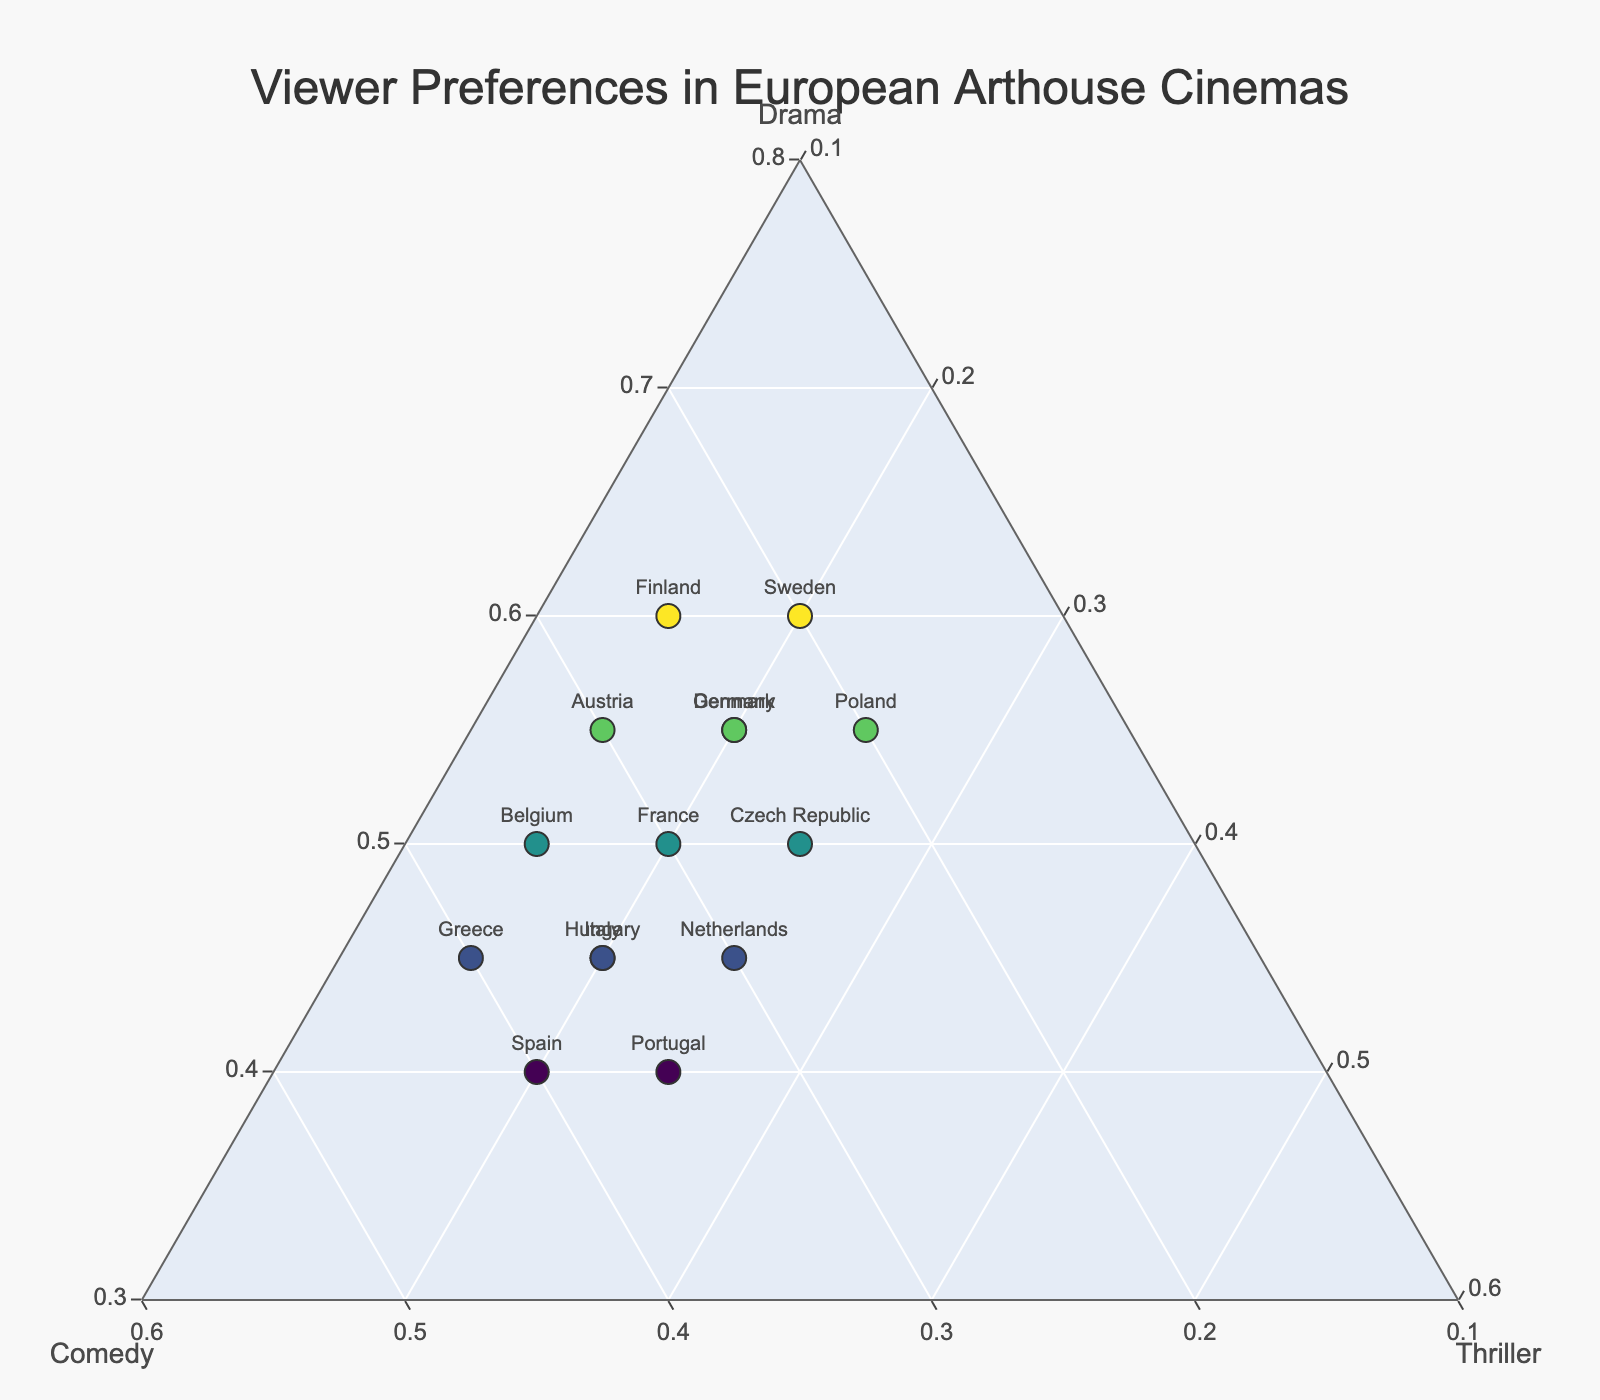Which country has the highest preference for Drama? You can identify the country with the highest percentage for Drama by looking at the points along the 'Drama' axis. The country with the highest value is Sweden with 60%.
Answer: Sweden Which countries have an equal preference for Comedy? You need to identify the countries that have the same value along the 'Comedy' axis. Both Greece and Spain have a 40% preference for Comedy.
Answer: Greece and Spain What's the difference in Thriller preference between Poland and Greece? Poland has a Thriller preference of 25%, and Greece has 15%. The difference is calculated as 25% - 15% = 10%.
Answer: 10% Which country has the most balanced viewer preferences? Balanced preferences would mean the values for Drama, Comedy, and Thriller are close to each other. Spain has 40% Drama, 40% Comedy, and 20% Thriller, which shows a good balance.
Answer: Spain How many countries have a Thriller preference below 20%? Count the number of countries where the Thriller value is less than 20%. Those countries are France, Belgium, Austria, Greece, and Finland, total is 5.
Answer: 5 Compare the Comedy preferences between France and the Netherlands. Which country has a higher preference? France has a Comedy preference of 30%, while the Netherlands has 30% as well. Since they are equal, neither has a higher preference.
Answer: Equal What's the average Drama preference across all countries? Sum up all the Drama preferences and divide by the number of countries: (50 + 45 + 55 + 40 + 60 + 45 + 55 + 50 + 55 + 40 + 45 + 50 + 55 + 45 + 60) / 15 = 50%.
Answer: 50% Which country prefers Thrillers the least? Identify the country with the lowest percentage for Thriller. Belgium has the lowest Thriller preference at 15%.
Answer: Belgium Compare the preferences for Comedy in Italy and Portugal. Which country has a higher percentage? Italy has a Comedy preference of 35%, while Portugal has 35% as well. Since they are equal, neither has a higher percentage.
Answer: Equal Among the countries with a Drama preference of 55%, which has the highest Thriller preference? Identify the countries with a Drama preference of 55% (Germany, Denmark, Austria, and Poland) and compare their Thriller preferences. Poland has the highest with 25%.
Answer: Poland 